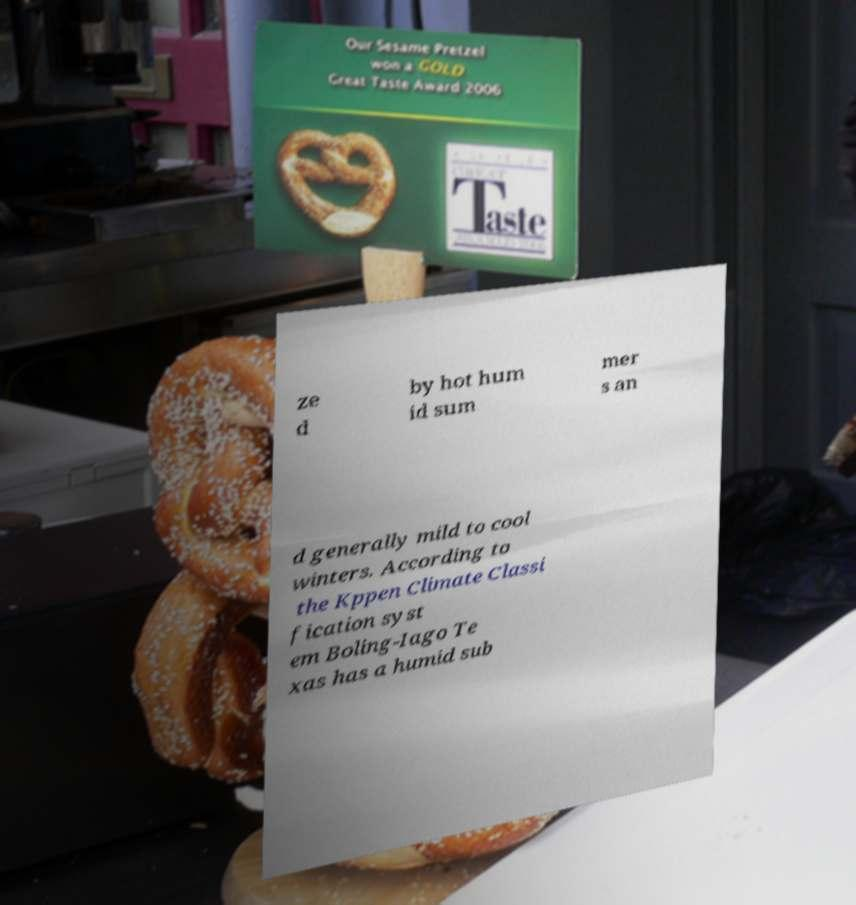Can you accurately transcribe the text from the provided image for me? ze d by hot hum id sum mer s an d generally mild to cool winters. According to the Kppen Climate Classi fication syst em Boling-Iago Te xas has a humid sub 